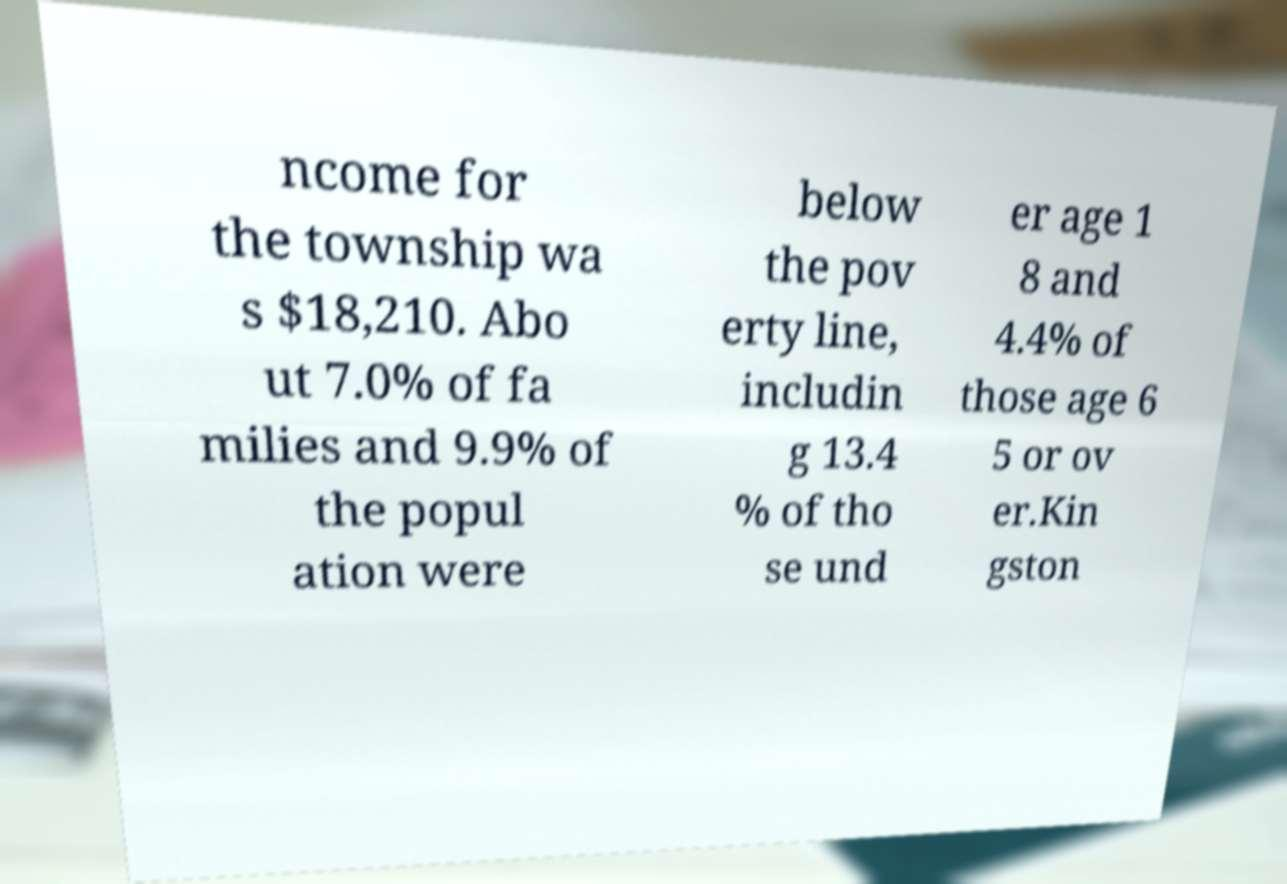For documentation purposes, I need the text within this image transcribed. Could you provide that? ncome for the township wa s $18,210. Abo ut 7.0% of fa milies and 9.9% of the popul ation were below the pov erty line, includin g 13.4 % of tho se und er age 1 8 and 4.4% of those age 6 5 or ov er.Kin gston 